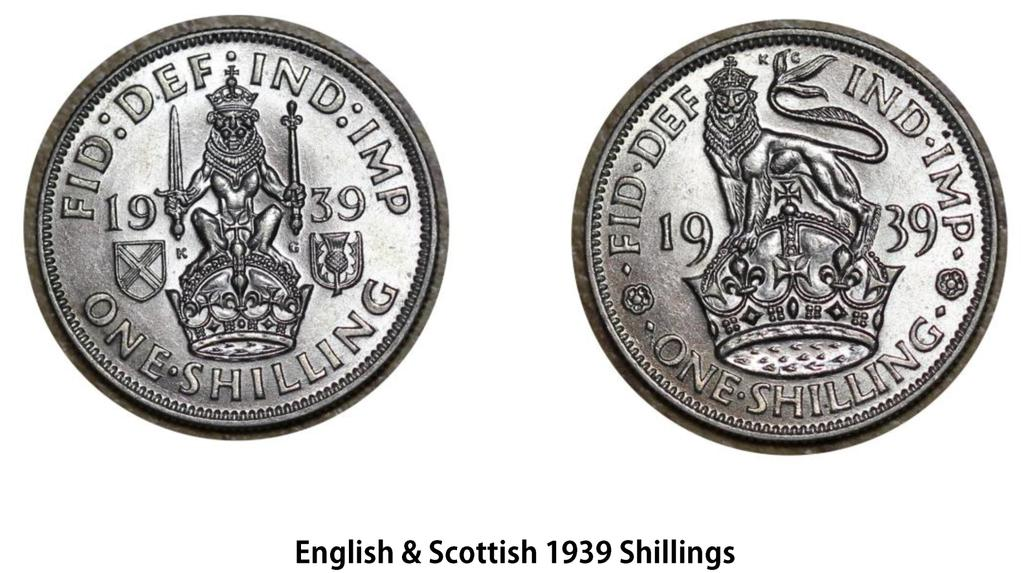Provide a one-sentence caption for the provided image. English and Scottish shillings from 1939 both feature crowns on them. 